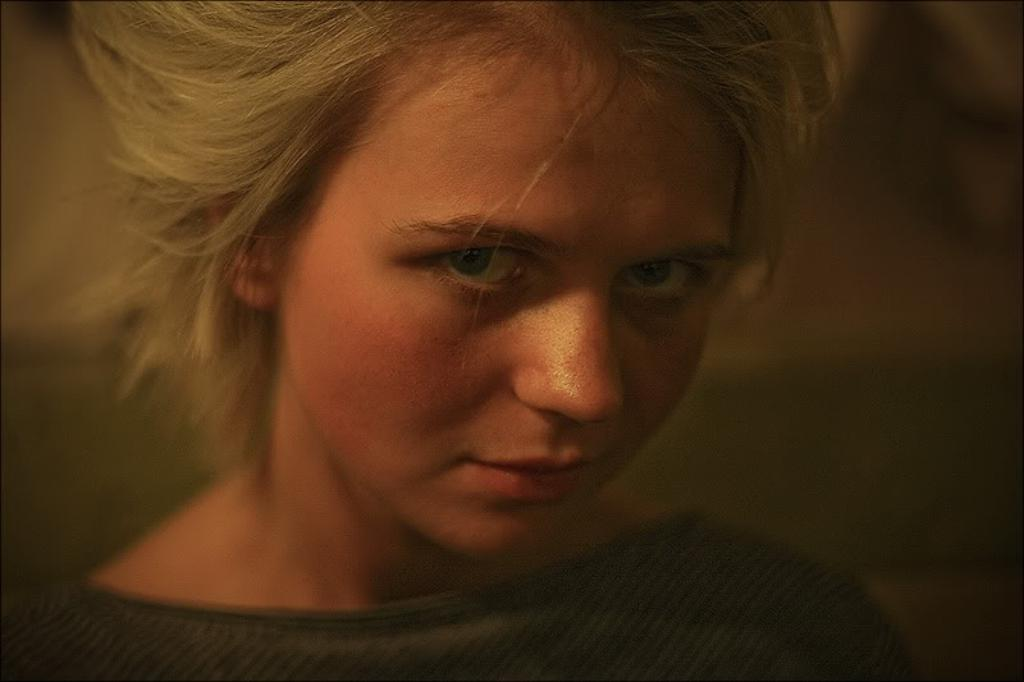What is the main subject of the image? There is a person in the image. Can you describe the background of the image? The background of the image is blurred. How many balloons are hanging on the calendar in the image? There is no calendar or balloons present in the image. What type of rest is the person taking in the image? There is no indication of the person resting or taking a break in the image. 